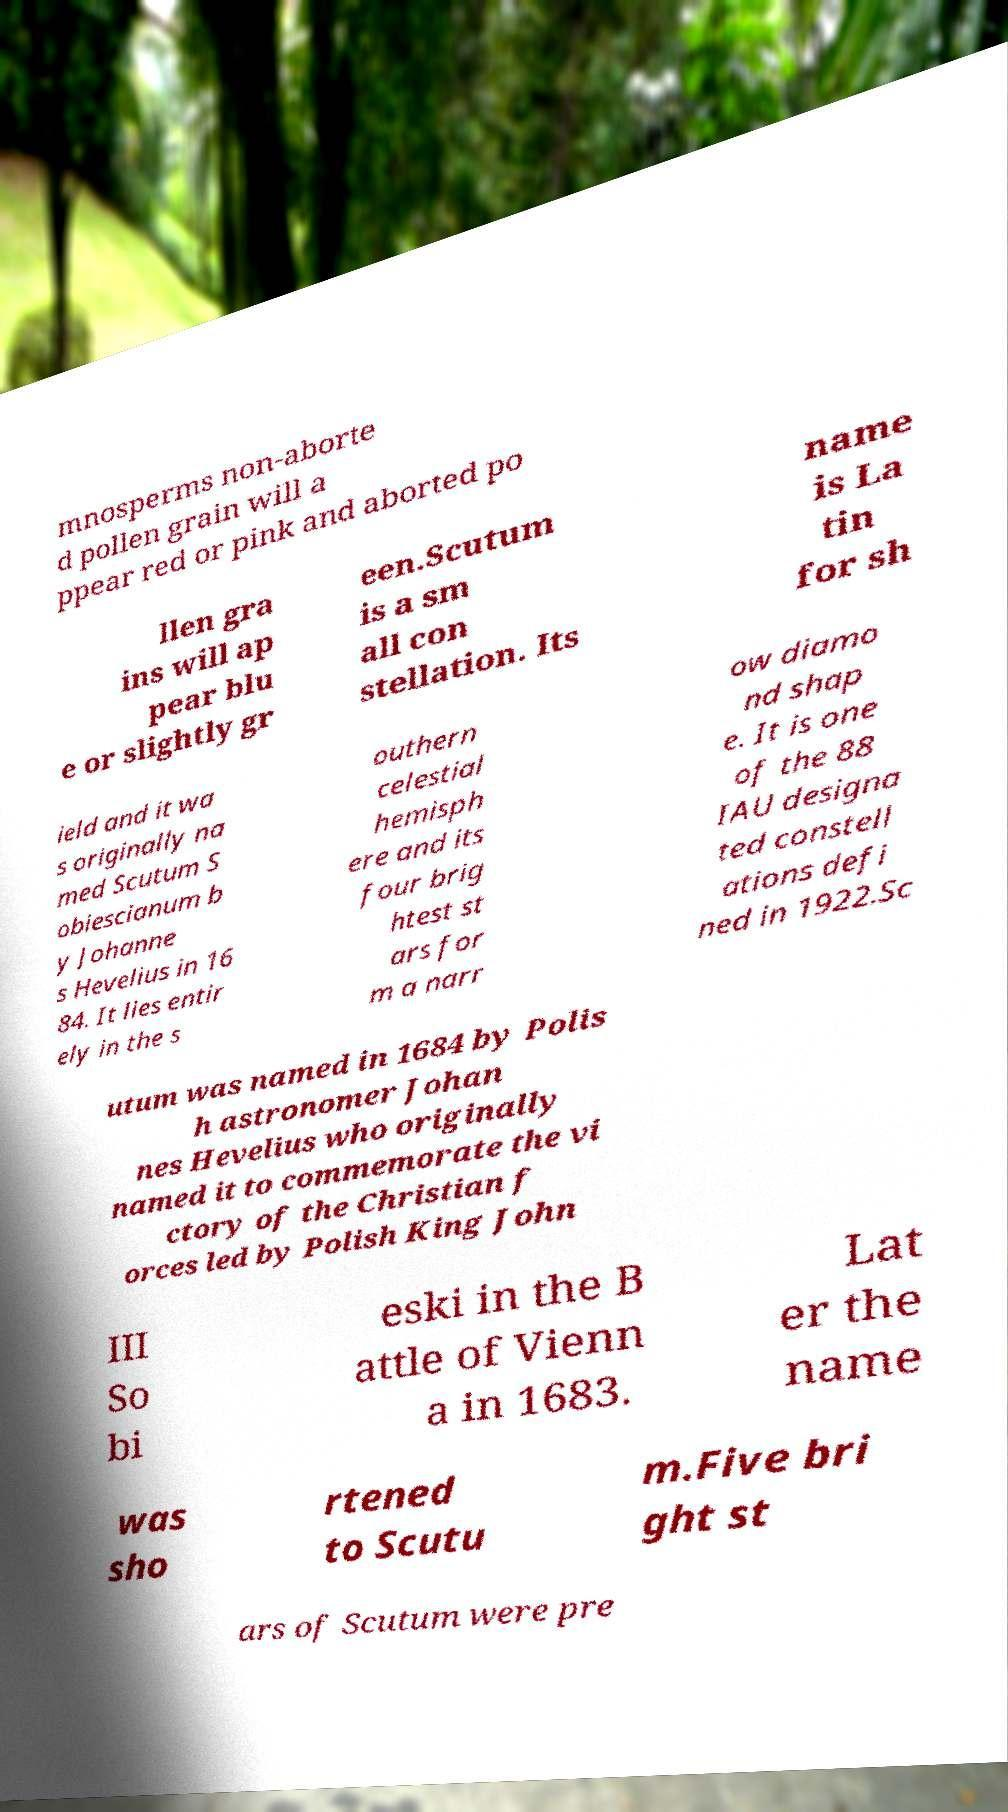There's text embedded in this image that I need extracted. Can you transcribe it verbatim? mnosperms non-aborte d pollen grain will a ppear red or pink and aborted po llen gra ins will ap pear blu e or slightly gr een.Scutum is a sm all con stellation. Its name is La tin for sh ield and it wa s originally na med Scutum S obiescianum b y Johanne s Hevelius in 16 84. It lies entir ely in the s outhern celestial hemisph ere and its four brig htest st ars for m a narr ow diamo nd shap e. It is one of the 88 IAU designa ted constell ations defi ned in 1922.Sc utum was named in 1684 by Polis h astronomer Johan nes Hevelius who originally named it to commemorate the vi ctory of the Christian f orces led by Polish King John III So bi eski in the B attle of Vienn a in 1683. Lat er the name was sho rtened to Scutu m.Five bri ght st ars of Scutum were pre 